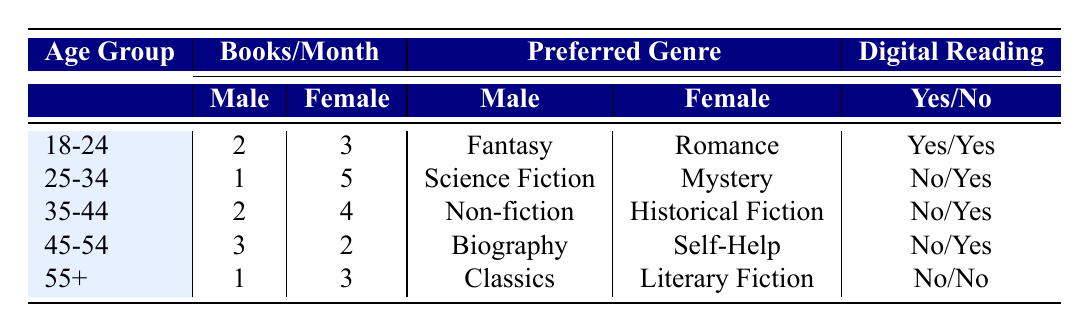What is the preferred genre of females aged 25-34? Referring to the table, under the age group 25-34, the row for female lists "Mystery" as the preferred genre.
Answer: Mystery How many books per month do males aged 45-54 read on average? From the table, males aged 45-54 read 3 books per month. Since there is only one entry for this age group, the average is simply 3.
Answer: 3 Is the preferred genre for males in the 55+ age group digital reading? Looking at the 55+ age group for males, their preferred genre is "Classics," and the digital reading column indicates "No," meaning they do not prefer digital reading.
Answer: No Which age group has the highest average number of books read per month? To find the average number of books read per month for each age group, we calculate: 18-24 = (2+3)/2 = 2.5, 25-34 = (1+5)/2 = 3, 35-44 = (2+4)/2 = 3, 45-54 = (3+2)/2 = 2.5, 55+ = (1+3)/2 = 2. The highest average number is 3 for the 25-34 age group.
Answer: 25-34 Do females aged 18-24 prefer digital reading? According to the table, females in the 18-24 age group have "Yes" listed under digital reading, indicating they do prefer digital reading.
Answer: Yes How many males are there in the age group 35-44? The table lists one entry for males in the 35-44 age group.
Answer: 1 What is the total number of books read per month by females aged 45-54? For females in the 45-54 age group, they read 2 books per month, so the total is simply 2 as there is only one entry for this age group.
Answer: 2 In which age group does the highest number of females prefer digital reading? By examining the table, the age group 25-34 has females reading 5 books per month and "Yes" for digital reading, which is the maximum.
Answer: 25-34 